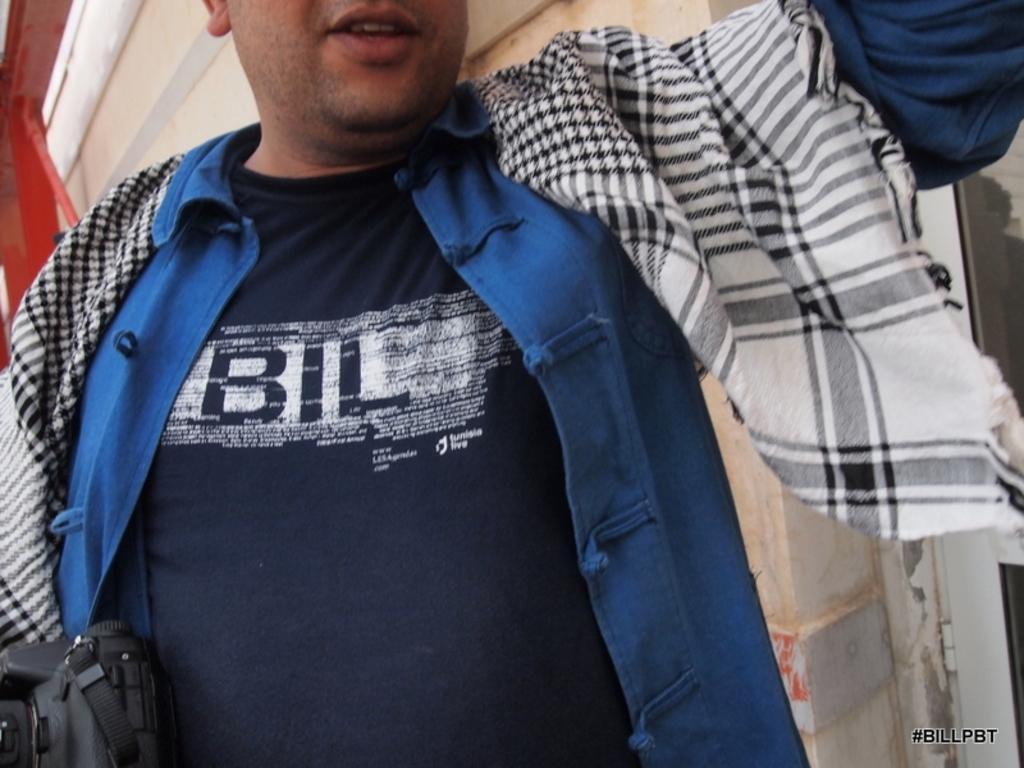In one or two sentences, can you explain what this image depicts? In the image there is a man, he is holding a camera his face is partially visible and behind the man there is a wall. 